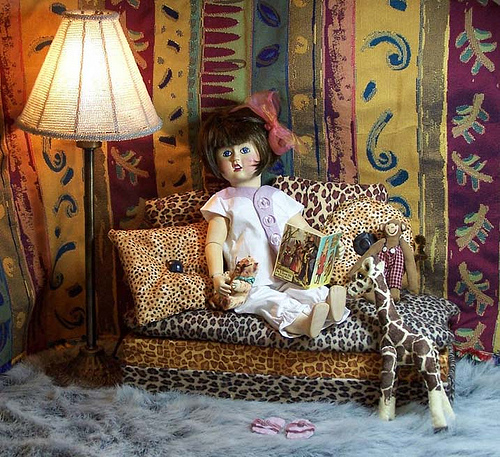<image>
Can you confirm if the lamp is to the left of the doll? Yes. From this viewpoint, the lamp is positioned to the left side relative to the doll. 